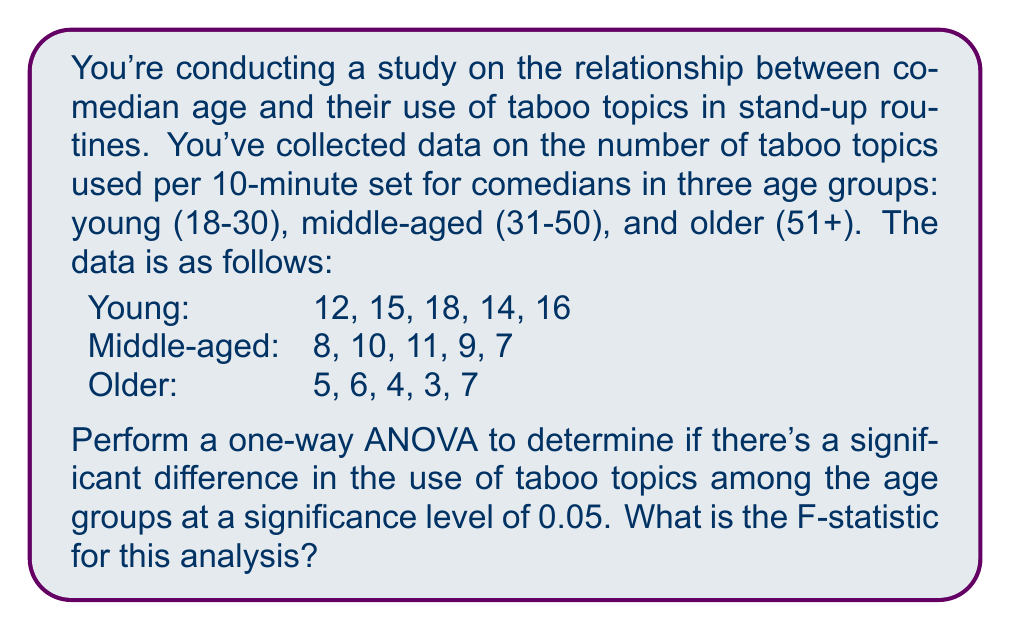Teach me how to tackle this problem. Let's perform a one-way ANOVA step-by-step:

1. Calculate the sum, mean, and sum of squares for each group:

Young: 
Sum = 75, Mean = 15, SS = 22

Middle-aged:
Sum = 45, Mean = 9, SS = 10

Older:
Sum = 25, Mean = 5, SS = 10

2. Calculate the total sum of squares (SST):
$$SST = \sum_{i=1}^{n} (x_i - \bar{x})^2$$
Where $\bar{x}$ is the grand mean (9.67).
SST = 330.67

3. Calculate the between-group sum of squares (SSB):
$$SSB = \sum_{i=1}^{k} n_i(\bar{x}_i - \bar{x})^2$$
Where $k$ is the number of groups, $n_i$ is the number of observations in each group, and $\bar{x}_i$ is the mean of each group.
SSB = 288.67

4. Calculate the within-group sum of squares (SSW):
$$SSW = SST - SSB$$
SSW = 42

5. Calculate the degrees of freedom:
df(between) = k - 1 = 2
df(within) = N - k = 12
Where N is the total number of observations.

6. Calculate the mean square between (MSB) and mean square within (MSW):
$$MSB = \frac{SSB}{df(between)} = 144.33$$
$$MSW = \frac{SSW}{df(within)} = 3.5$$

7. Calculate the F-statistic:
$$F = \frac{MSB}{MSW} = \frac{144.33}{3.5} = 41.24$$
Answer: The F-statistic for this analysis is 41.24. 